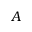Convert formula to latex. <formula><loc_0><loc_0><loc_500><loc_500>A</formula> 